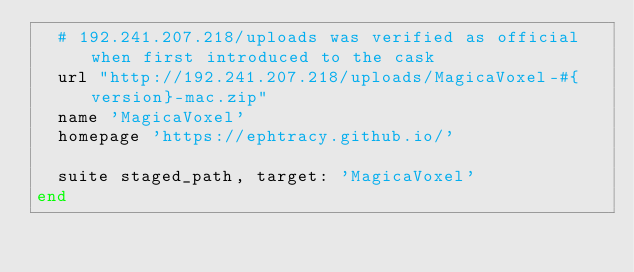<code> <loc_0><loc_0><loc_500><loc_500><_Ruby_>  # 192.241.207.218/uploads was verified as official when first introduced to the cask
  url "http://192.241.207.218/uploads/MagicaVoxel-#{version}-mac.zip"
  name 'MagicaVoxel'
  homepage 'https://ephtracy.github.io/'

  suite staged_path, target: 'MagicaVoxel'
end
</code> 